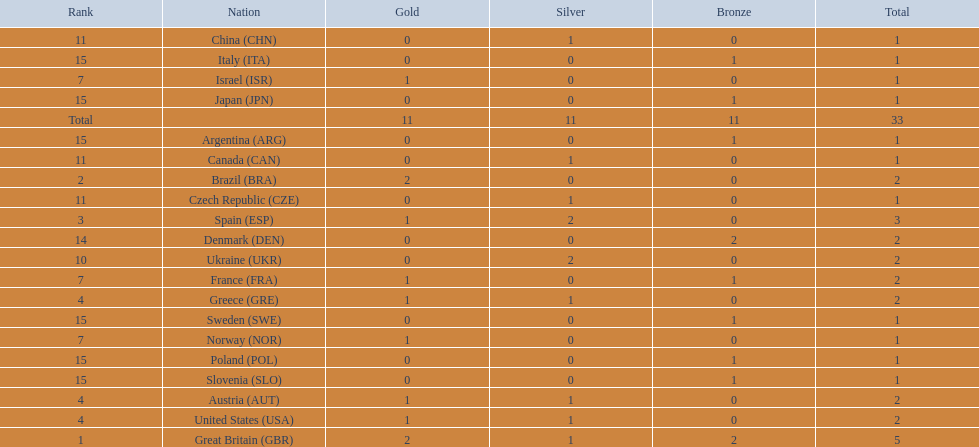How many medals did spain gain 3. Only country that got more medals? Spain (ESP). 